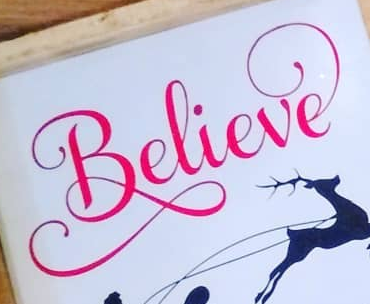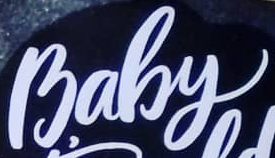Identify the words shown in these images in order, separated by a semicolon. Believe; Baby 